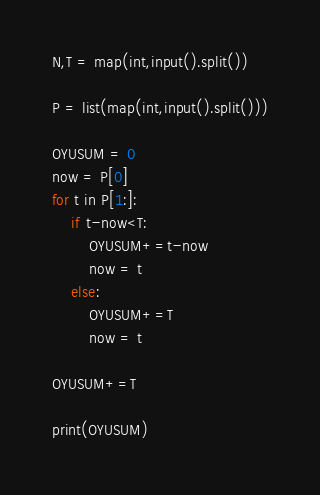<code> <loc_0><loc_0><loc_500><loc_500><_Python_>N,T = map(int,input().split())

P = list(map(int,input().split()))

OYUSUM = 0
now = P[0]
for t in P[1:]:
    if t-now<T:
        OYUSUM+=t-now
        now = t
    else:
        OYUSUM+=T
        now = t
    
OYUSUM+=T
    
print(OYUSUM)</code> 